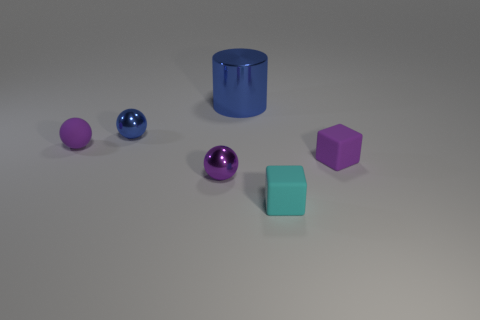Add 2 tiny green metal spheres. How many objects exist? 8 Subtract all blocks. How many objects are left? 4 Subtract 0 red cubes. How many objects are left? 6 Subtract all small purple shiny things. Subtract all small blue spheres. How many objects are left? 4 Add 6 metallic cylinders. How many metallic cylinders are left? 7 Add 1 small blue objects. How many small blue objects exist? 2 